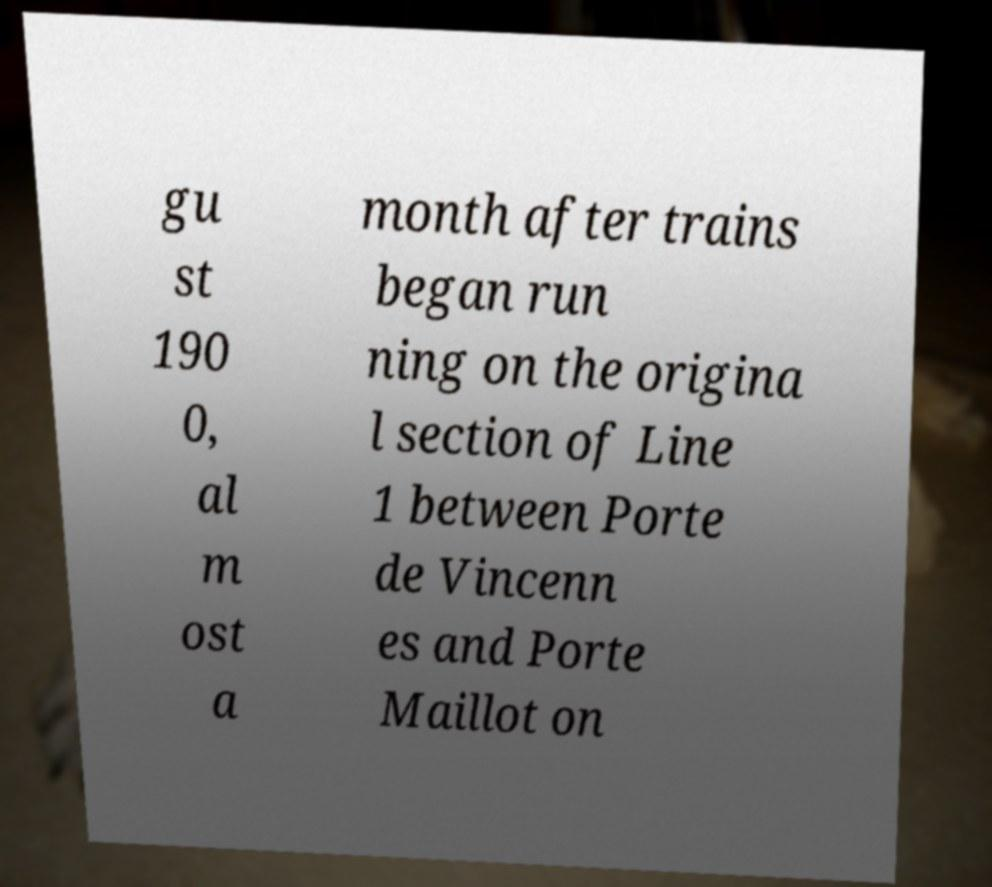Please read and relay the text visible in this image. What does it say? gu st 190 0, al m ost a month after trains began run ning on the origina l section of Line 1 between Porte de Vincenn es and Porte Maillot on 